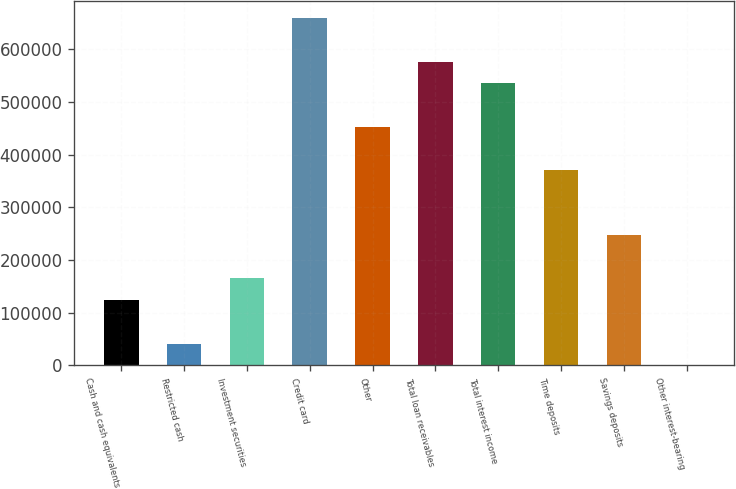Convert chart. <chart><loc_0><loc_0><loc_500><loc_500><bar_chart><fcel>Cash and cash equivalents<fcel>Restricted cash<fcel>Investment securities<fcel>Credit card<fcel>Other<fcel>Total loan receivables<fcel>Total interest income<fcel>Time deposits<fcel>Savings deposits<fcel>Other interest-bearing<nl><fcel>123663<fcel>41265.8<fcel>164862<fcel>659248<fcel>453254<fcel>576850<fcel>535651<fcel>370856<fcel>247260<fcel>67<nl></chart> 